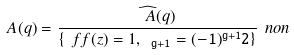Convert formula to latex. <formula><loc_0><loc_0><loc_500><loc_500>\ A ( q ) = \frac { \widehat { \ A } ( q ) } { \{ \ f f ( z ) = 1 , \ \tt _ { g + 1 } = ( - 1 ) ^ { g + 1 } 2 \} } \ n o n</formula> 